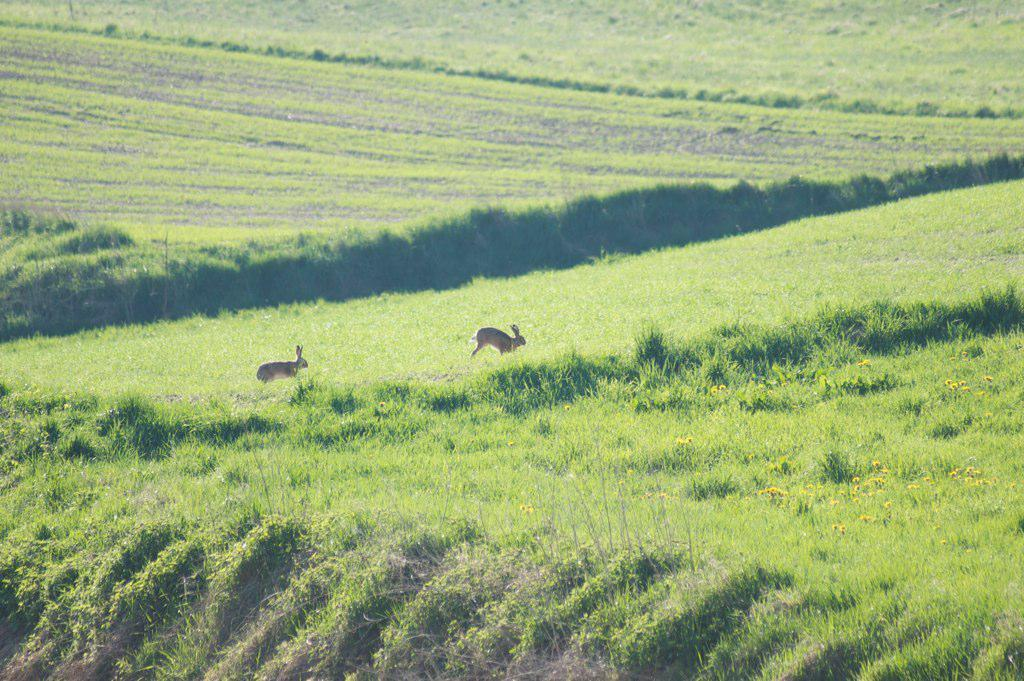What type of surface is visible in the image? There is ground visible in the image. What is covering the ground? There is grass on the ground. What other types of vegetation can be seen in the image? There are plants in the image. How many animals are present in the image? There are two animals in the image. What is the purpose of the baby in the image? There is no baby present in the image. What month does the image represent? The image does not represent a specific month. 